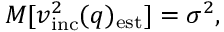Convert formula to latex. <formula><loc_0><loc_0><loc_500><loc_500>M [ v _ { i n c } ^ { 2 } ( q ) _ { e s t } ] = \sigma ^ { 2 } ,</formula> 